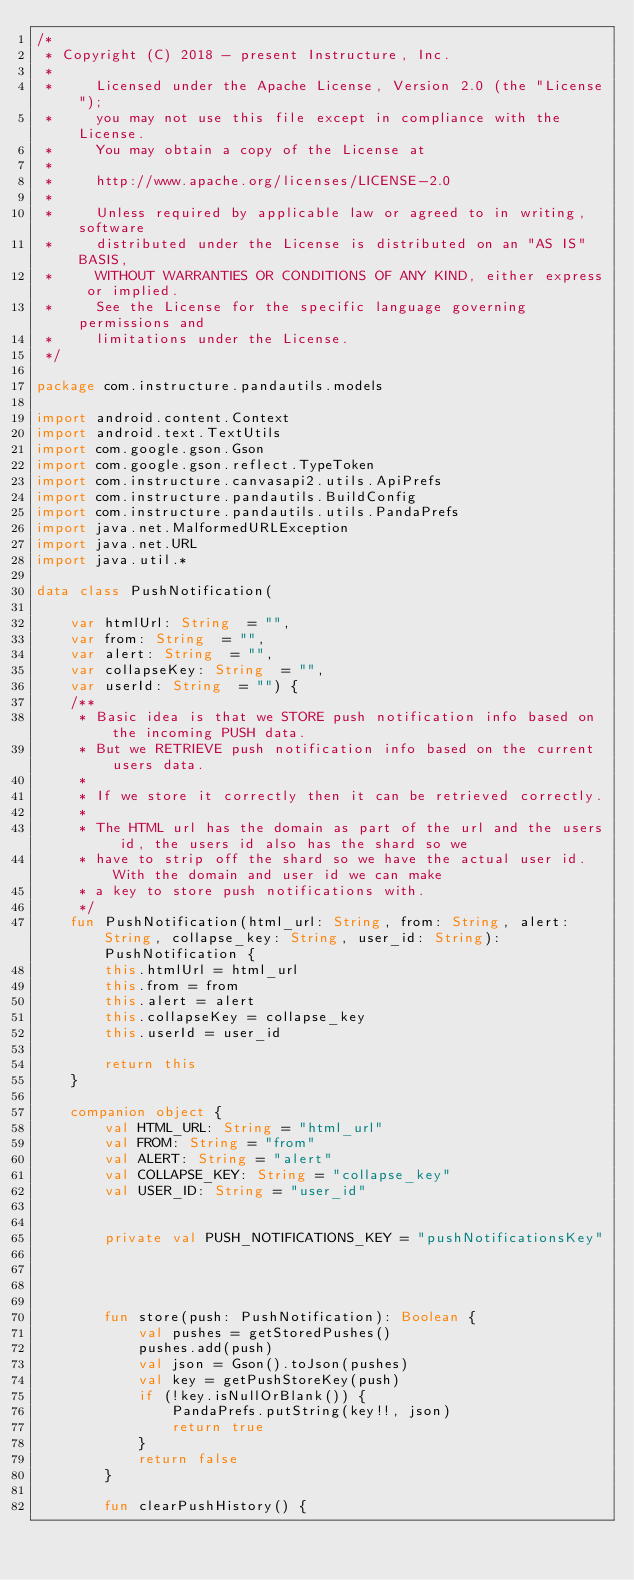<code> <loc_0><loc_0><loc_500><loc_500><_Kotlin_>/*
 * Copyright (C) 2018 - present Instructure, Inc.
 *
 *     Licensed under the Apache License, Version 2.0 (the "License");
 *     you may not use this file except in compliance with the License.
 *     You may obtain a copy of the License at
 *
 *     http://www.apache.org/licenses/LICENSE-2.0
 *
 *     Unless required by applicable law or agreed to in writing, software
 *     distributed under the License is distributed on an "AS IS" BASIS,
 *     WITHOUT WARRANTIES OR CONDITIONS OF ANY KIND, either express or implied.
 *     See the License for the specific language governing permissions and
 *     limitations under the License.
 */

package com.instructure.pandautils.models

import android.content.Context
import android.text.TextUtils
import com.google.gson.Gson
import com.google.gson.reflect.TypeToken
import com.instructure.canvasapi2.utils.ApiPrefs
import com.instructure.pandautils.BuildConfig
import com.instructure.pandautils.utils.PandaPrefs
import java.net.MalformedURLException
import java.net.URL
import java.util.*

data class PushNotification(

    var htmlUrl: String  = "",
    var from: String  = "",
    var alert: String  = "",
    var collapseKey: String  = "",
    var userId: String  = "") {
    /**
     * Basic idea is that we STORE push notification info based on the incoming PUSH data.
     * But we RETRIEVE push notification info based on the current users data.
     *
     * If we store it correctly then it can be retrieved correctly.
     *
     * The HTML url has the domain as part of the url and the users id, the users id also has the shard so we
     * have to strip off the shard so we have the actual user id. With the domain and user id we can make
     * a key to store push notifications with.
     */
    fun PushNotification(html_url: String, from: String, alert: String, collapse_key: String, user_id: String): PushNotification {
        this.htmlUrl = html_url
        this.from = from
        this.alert = alert
        this.collapseKey = collapse_key
        this.userId = user_id

        return this
    }

    companion object {
        val HTML_URL: String = "html_url"
        val FROM: String = "from"
        val ALERT: String = "alert"
        val COLLAPSE_KEY: String = "collapse_key"
        val USER_ID: String = "user_id"


        private val PUSH_NOTIFICATIONS_KEY = "pushNotificationsKey"




        fun store(push: PushNotification): Boolean {
            val pushes = getStoredPushes()
            pushes.add(push)
            val json = Gson().toJson(pushes)
            val key = getPushStoreKey(push)
            if (!key.isNullOrBlank()) {
                PandaPrefs.putString(key!!, json)
                return true
            }
            return false
        }

        fun clearPushHistory() {</code> 